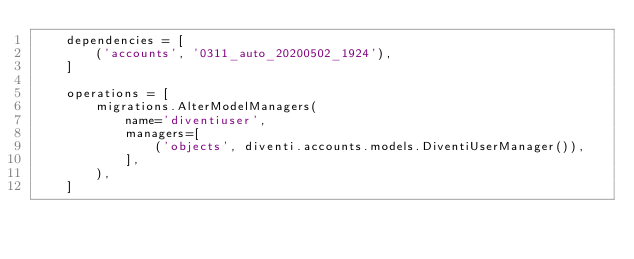<code> <loc_0><loc_0><loc_500><loc_500><_Python_>    dependencies = [
        ('accounts', '0311_auto_20200502_1924'),
    ]

    operations = [
        migrations.AlterModelManagers(
            name='diventiuser',
            managers=[
                ('objects', diventi.accounts.models.DiventiUserManager()),
            ],
        ),
    ]
</code> 